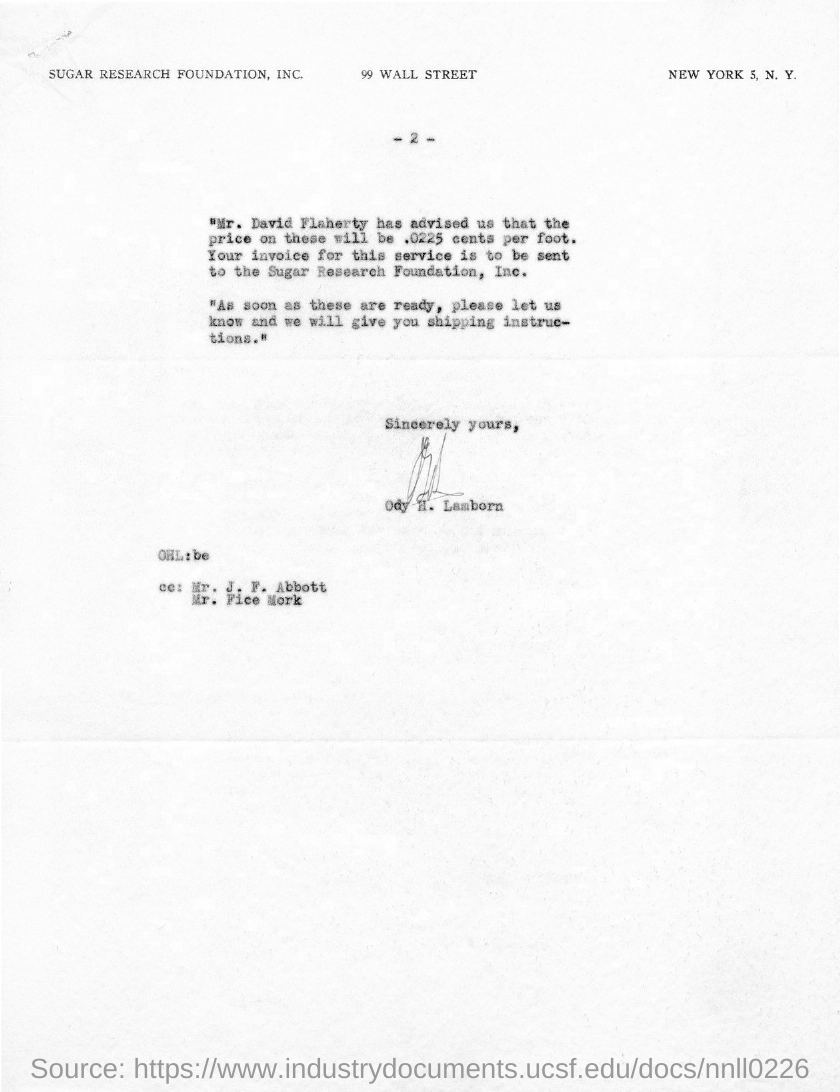Outline some significant characteristics in this image. The document contains a page number mentioned as "What is the page no mentioned in this document? -2-.. 